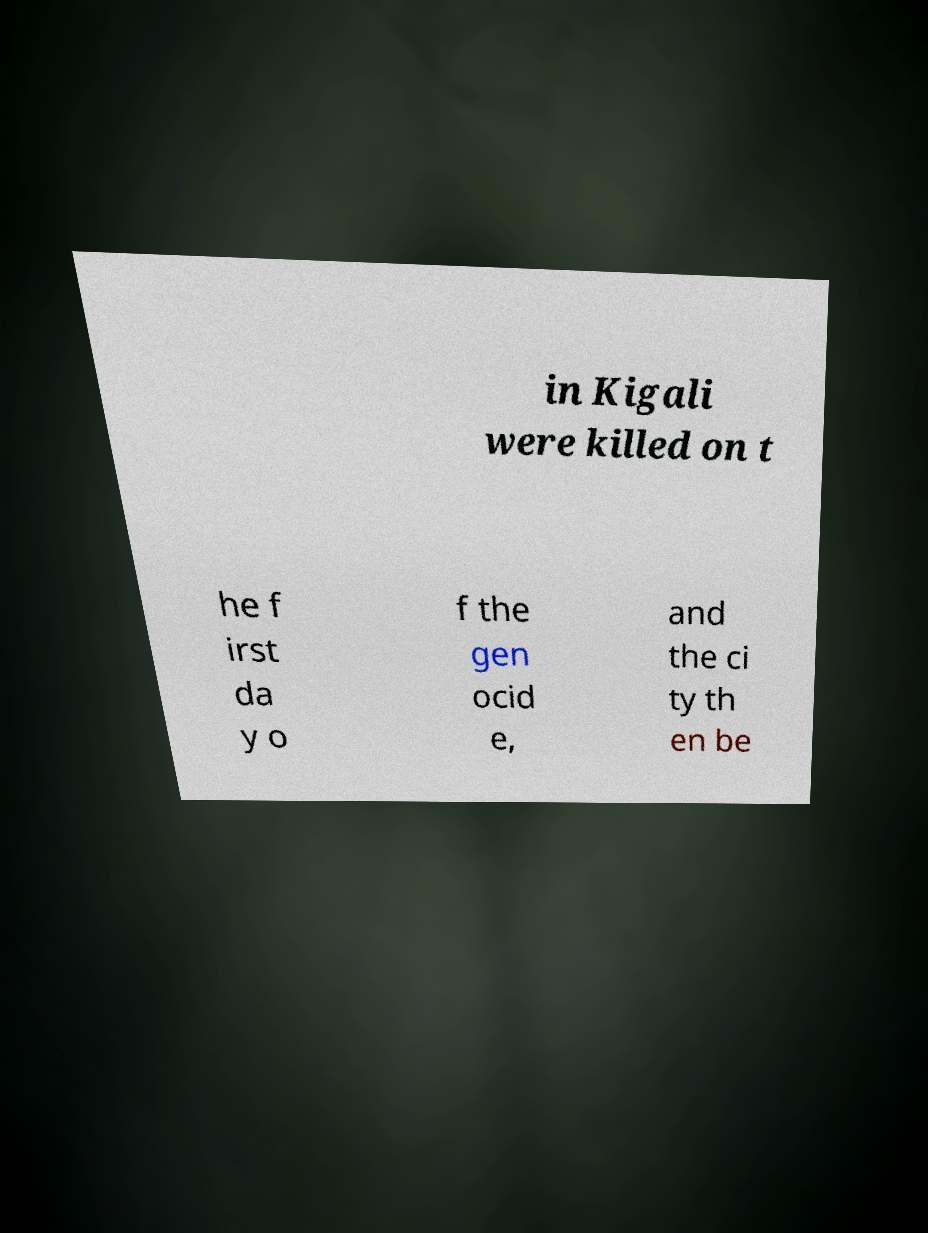Please identify and transcribe the text found in this image. in Kigali were killed on t he f irst da y o f the gen ocid e, and the ci ty th en be 